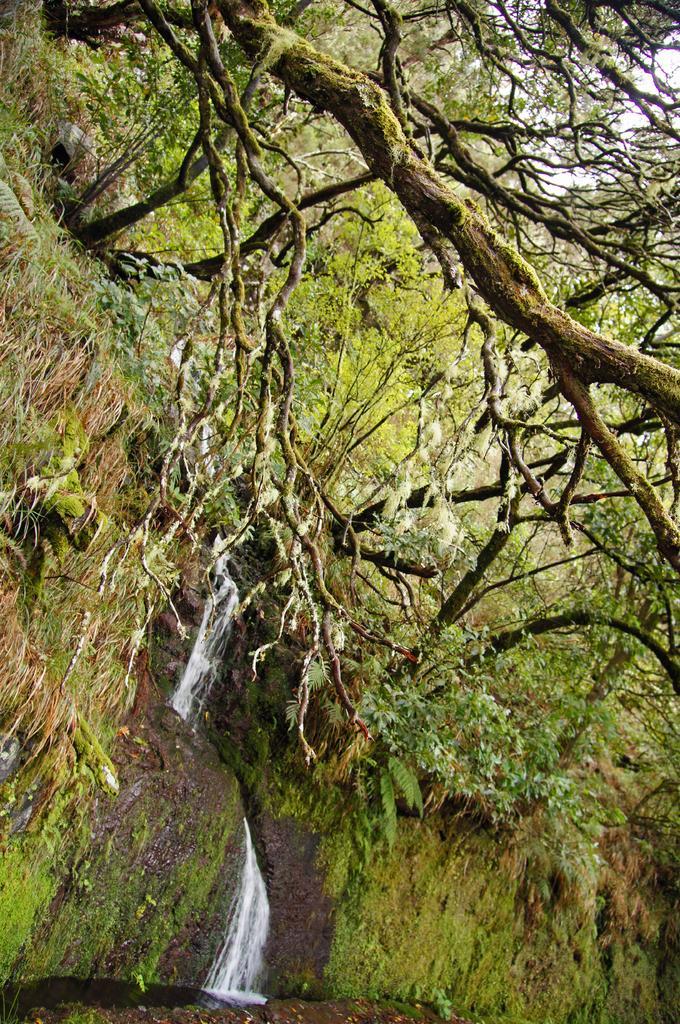Can you describe this image briefly? In this image we can see a group of trees, plants and the grass. In the middle we can see the waterfall. In the top right, we can see the sky. 